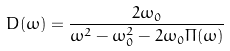<formula> <loc_0><loc_0><loc_500><loc_500>D ( \omega ) = \frac { 2 \omega _ { 0 } } { \omega ^ { 2 } - \omega _ { 0 } ^ { 2 } - 2 \omega _ { 0 } \Pi ( \omega ) }</formula> 